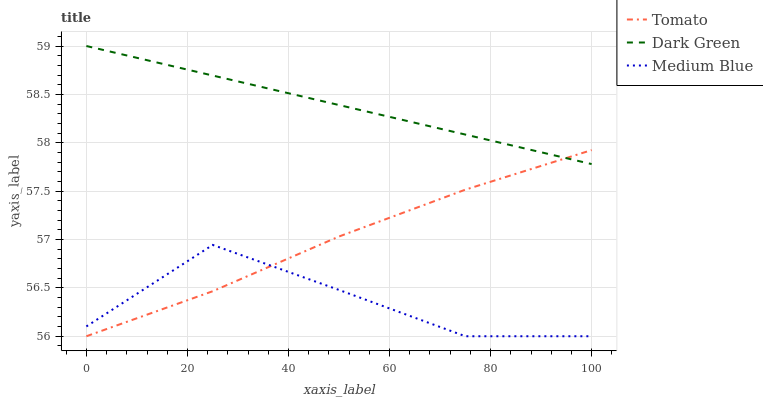Does Dark Green have the minimum area under the curve?
Answer yes or no. No. Does Medium Blue have the maximum area under the curve?
Answer yes or no. No. Is Medium Blue the smoothest?
Answer yes or no. No. Is Dark Green the roughest?
Answer yes or no. No. Does Dark Green have the lowest value?
Answer yes or no. No. Does Medium Blue have the highest value?
Answer yes or no. No. Is Medium Blue less than Dark Green?
Answer yes or no. Yes. Is Dark Green greater than Medium Blue?
Answer yes or no. Yes. Does Medium Blue intersect Dark Green?
Answer yes or no. No. 